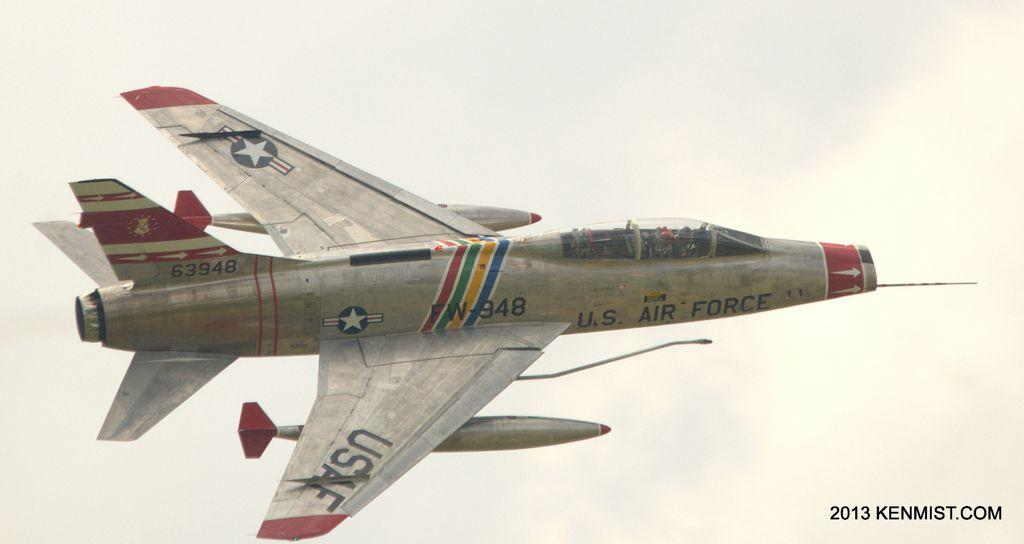What is the main subject of the image? The main subject of the image is an airplane. In which direction is the airplane flying? The airplane is flying towards the right side. What can be seen in the background of the image? The sky is visible in the background of the image. Is there any text present in the image? Yes, there is some text in the bottom right corner of the image. How many women are operating the machine in the image? There is no machine or women present in the image; it features an airplane flying towards the right side. 